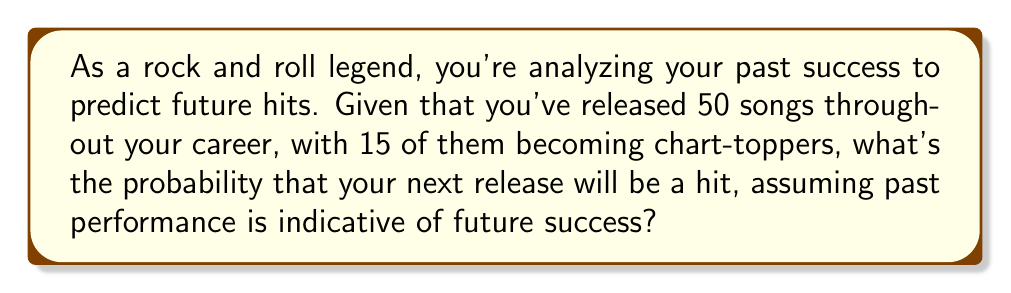What is the answer to this math problem? To solve this problem, we'll use the concept of relative frequency as an estimate of probability. The relative frequency approach suggests that if an event has occurred $m$ times in $n$ trials, the probability of that event occurring in the future can be estimated as $\frac{m}{n}$.

Let's break down the given information:
- Total number of songs released: $n = 50$
- Number of hit songs: $m = 15$

The probability of the next song being a hit can be calculated as follows:

$$P(\text{Hit}) = \frac{\text{Number of hit songs}}{\text{Total number of songs}}$$

$$P(\text{Hit}) = \frac{m}{n} = \frac{15}{50}$$

To simplify this fraction:

$$\frac{15}{50} = \frac{3}{10} = 0.3$$

This can also be expressed as a percentage:

$$0.3 \times 100\% = 30\%$$

Therefore, based on your historical performance, there's a 30% chance that your next song will be a hit.

It's important to note that this is a simplified model and doesn't take into account factors such as changes in musical trends, your current popularity, or the quality of the new song. In reality, the probability of a hit might be influenced by many additional factors.
Answer: $P(\text{Hit}) = 0.3$ or $30\%$ 